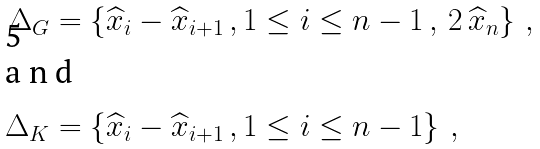Convert formula to latex. <formula><loc_0><loc_0><loc_500><loc_500>\Delta _ { G } & = \left \{ \widehat { x } _ { i } - \widehat { x } _ { i + 1 } \, , 1 \leq i \leq n - 1 \, , \, 2 \, \widehat { x } _ { n } \right \} \, , \\ \intertext { a n d } \Delta _ { K } & = \left \{ \widehat { x } _ { i } - \widehat { x } _ { i + 1 } \, , 1 \leq i \leq n - 1 \right \} \, ,</formula> 